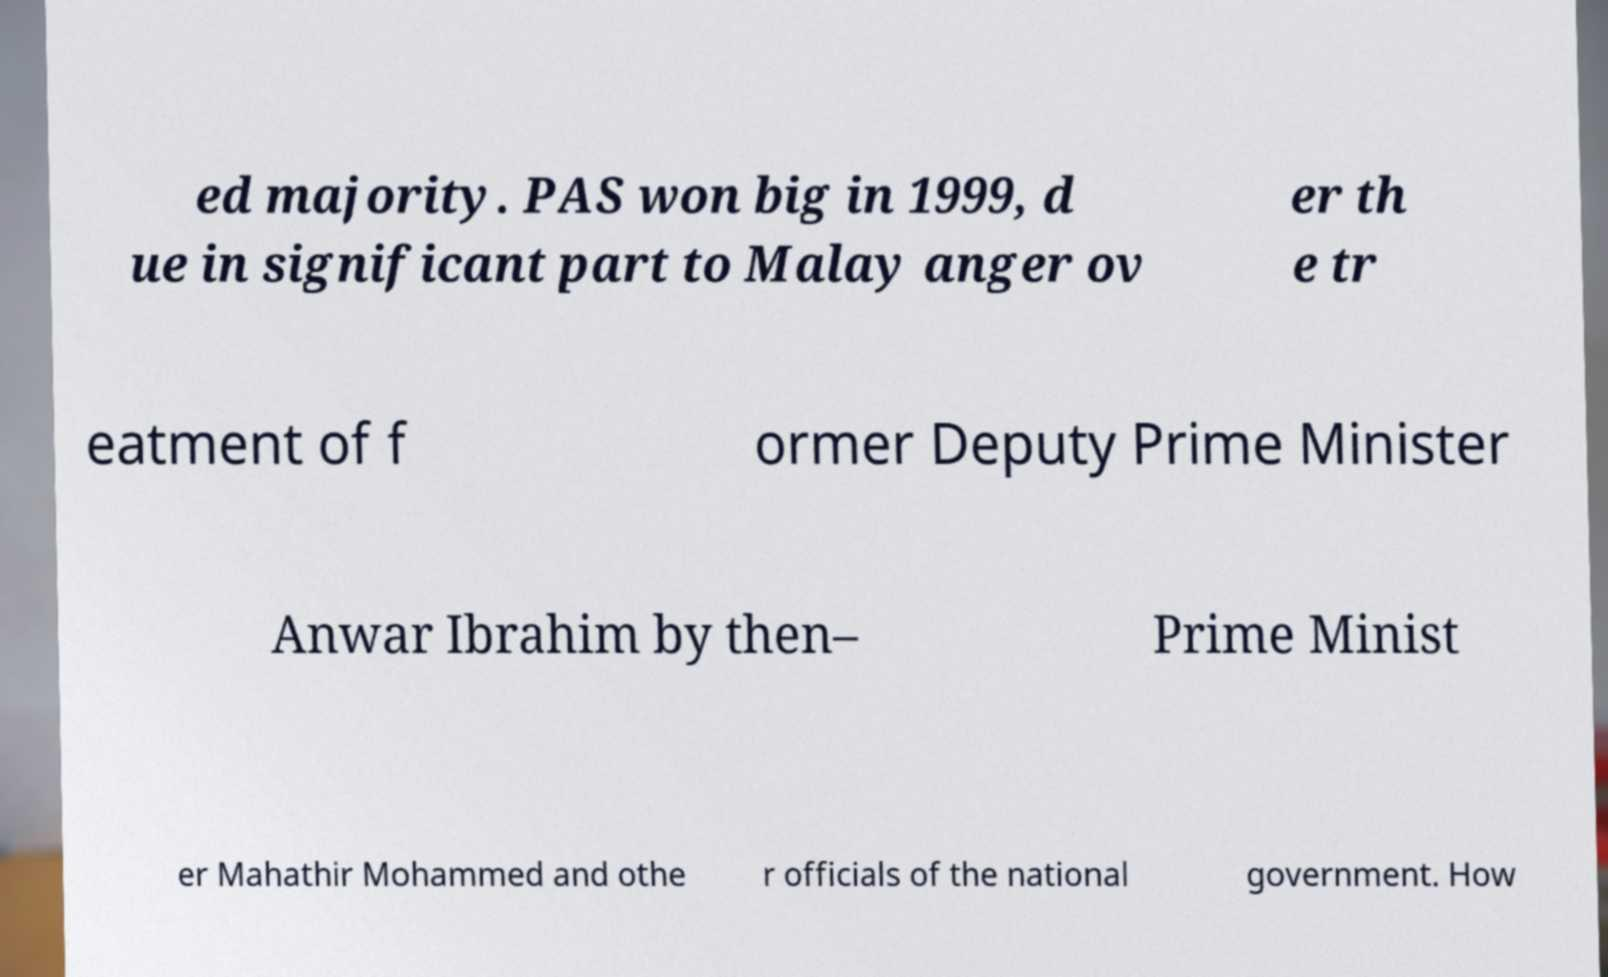There's text embedded in this image that I need extracted. Can you transcribe it verbatim? ed majority. PAS won big in 1999, d ue in significant part to Malay anger ov er th e tr eatment of f ormer Deputy Prime Minister Anwar Ibrahim by then– Prime Minist er Mahathir Mohammed and othe r officials of the national government. How 